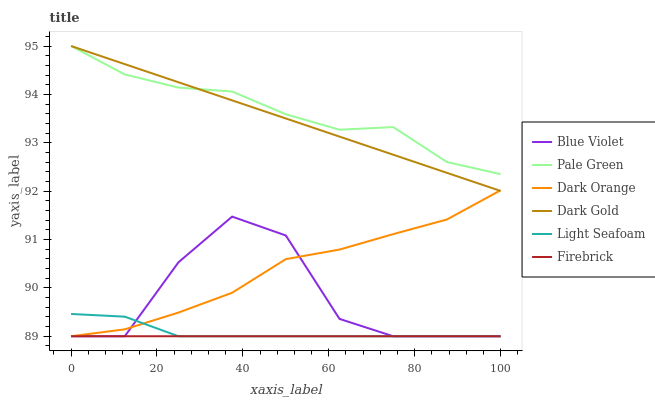Does Firebrick have the minimum area under the curve?
Answer yes or no. Yes. Does Pale Green have the maximum area under the curve?
Answer yes or no. Yes. Does Dark Gold have the minimum area under the curve?
Answer yes or no. No. Does Dark Gold have the maximum area under the curve?
Answer yes or no. No. Is Firebrick the smoothest?
Answer yes or no. Yes. Is Blue Violet the roughest?
Answer yes or no. Yes. Is Dark Gold the smoothest?
Answer yes or no. No. Is Dark Gold the roughest?
Answer yes or no. No. Does Dark Orange have the lowest value?
Answer yes or no. Yes. Does Dark Gold have the lowest value?
Answer yes or no. No. Does Pale Green have the highest value?
Answer yes or no. Yes. Does Firebrick have the highest value?
Answer yes or no. No. Is Firebrick less than Pale Green?
Answer yes or no. Yes. Is Dark Gold greater than Light Seafoam?
Answer yes or no. Yes. Does Light Seafoam intersect Dark Orange?
Answer yes or no. Yes. Is Light Seafoam less than Dark Orange?
Answer yes or no. No. Is Light Seafoam greater than Dark Orange?
Answer yes or no. No. Does Firebrick intersect Pale Green?
Answer yes or no. No. 